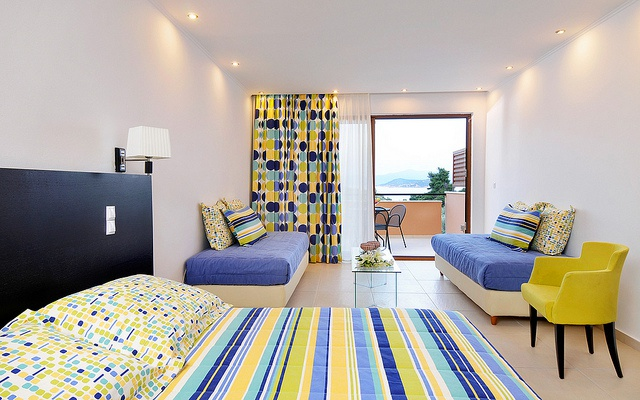Describe the objects in this image and their specific colors. I can see bed in lightgray, white, black, and khaki tones, chair in lightgray, olive, gold, black, and tan tones, couch in lightgray, darkgray, blue, and tan tones, bed in lightgray, blue, tan, and darkgray tones, and bed in lightgray, darkgray, blue, and tan tones in this image. 